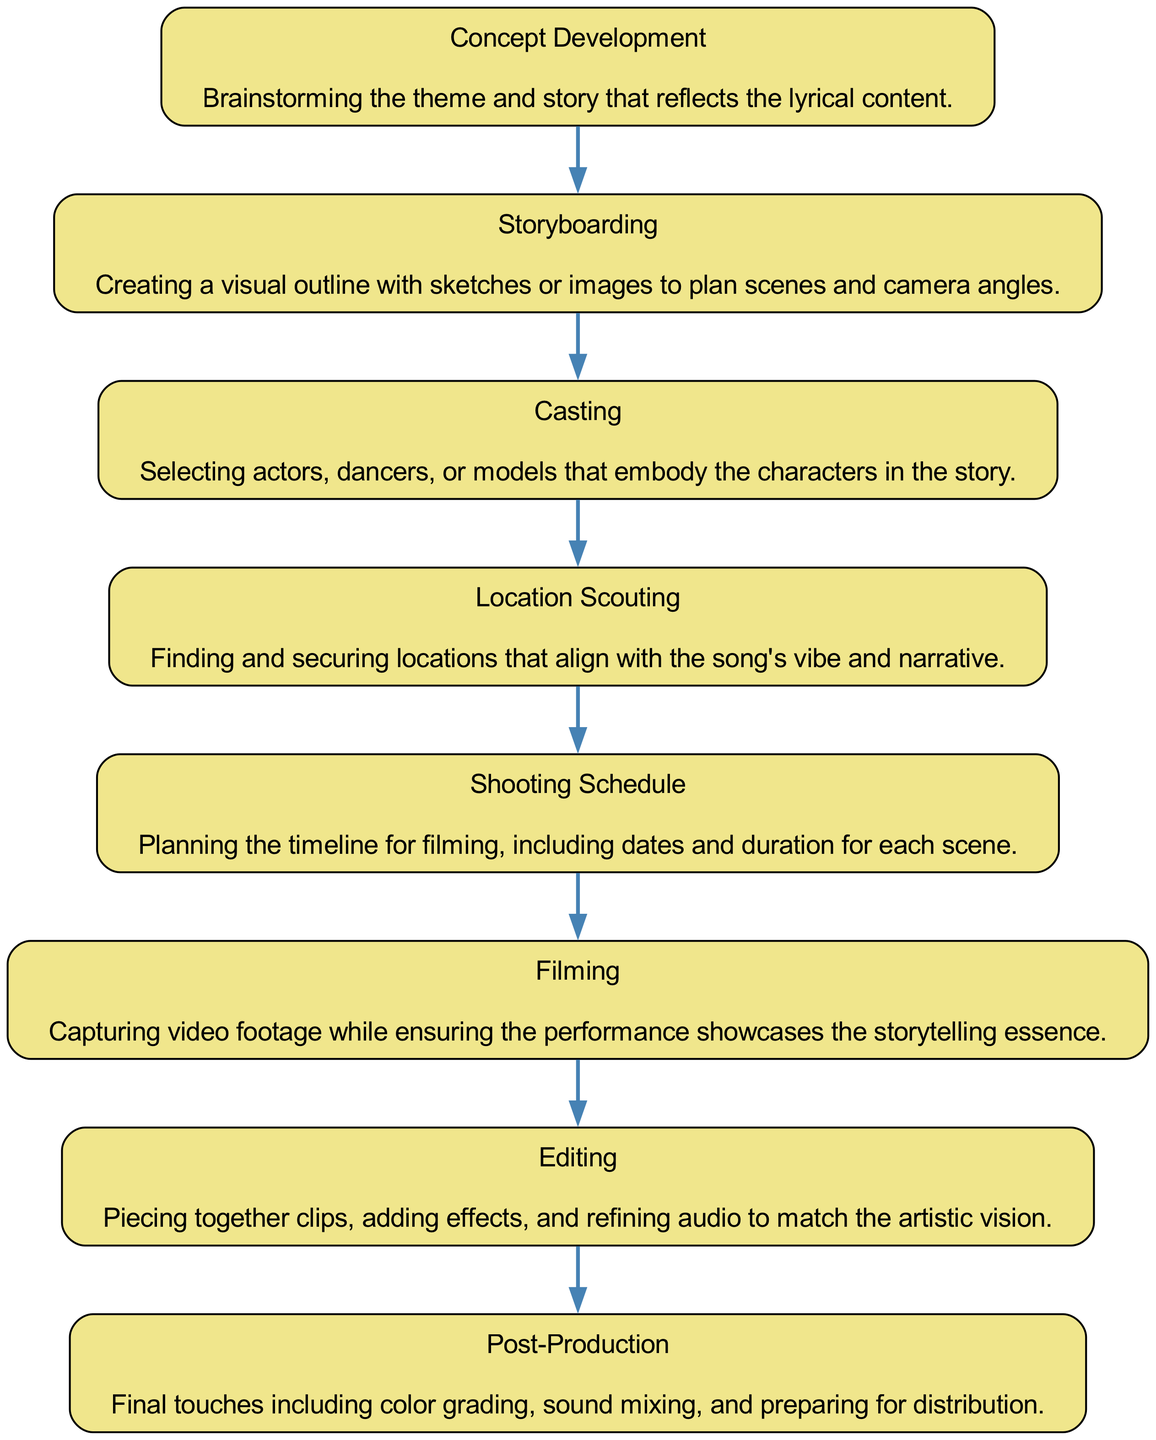What is the first stage in the diagram? The first stage listed in the diagram is "Concept Development." By looking at the flow chart, we can identify that this is the starting point of the production process, as no other stage precedes it.
Answer: Concept Development How many stages are presented in the diagram? The flow chart features eight distinct stages. By counting the nodes labeled in the diagram, each representing a phase of music video production, we reach a total of eight stages.
Answer: Eight What comes directly after the Storyboarding stage? Following the Storyboarding stage in the flow chart is the "Casting" stage. This can be determined by checking the order of the nodes in the visual representation, where Casting is the next node after Storyboarding.
Answer: Casting What is involved in the Editing phase? The Editing phase is described as "Piecing together clips, adding effects, and refining audio to match the artistic vision." This information is sourced from the description connected to the node labeled Editing in the flow chart.
Answer: Piecing together clips, adding effects, and refining audio Which stage focuses on securing filming locations? The stage that focuses on securing filming locations is "Location Scouting." This is evident from the specific mention of finding and securing locations that align with the song’s vibe and narrative within the diagram.
Answer: Location Scouting What is the relationship between Filming and Editing? The relationship between Filming and Editing is sequential; Editing directly follows Filming in the production process as the next stage. This can be confirmed by tracing the flow from Filming to the subsequent node, which is Editing.
Answer: Sequential Which two phases directly precede Post-Production? The two phases directly preceding Post-Production are "Editing" and "Filming." By examining the flow chart, we see that Editing comes right before Post-Production, with Filming directly leading into Editing.
Answer: Editing and Filming What is typically captured during the Filming phase? The description of the Filming phase indicates that the video footage captured focuses on showcasing the storytelling essence. This word choice is tied to the objectives outlined in the Filming node of the diagram.
Answer: Video footage showcasing storytelling essence What is the last stage of the music video production process? The last stage in the flow chart is "Post-Production." This is clear by identifying that it is the terminal node in the diagram, marking the end of the music video production sequence.
Answer: Post-Production 